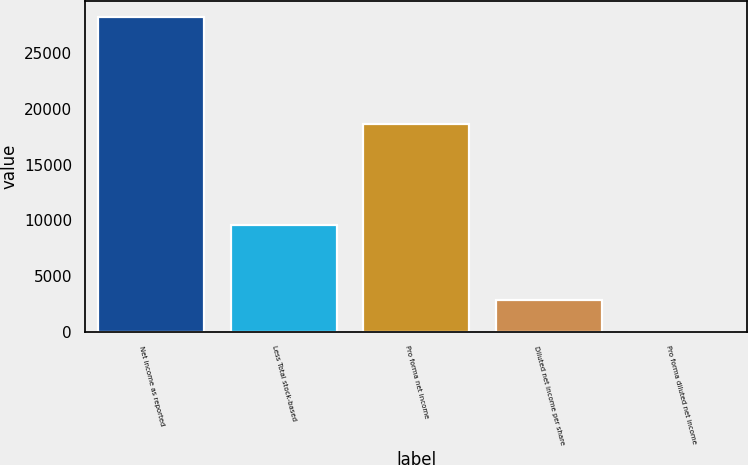<chart> <loc_0><loc_0><loc_500><loc_500><bar_chart><fcel>Net income as reported<fcel>Less Total stock-based<fcel>Pro forma net income<fcel>Diluted net income per share<fcel>Pro forma diluted net income<nl><fcel>28256<fcel>9614<fcel>18642<fcel>2825.97<fcel>0.41<nl></chart> 